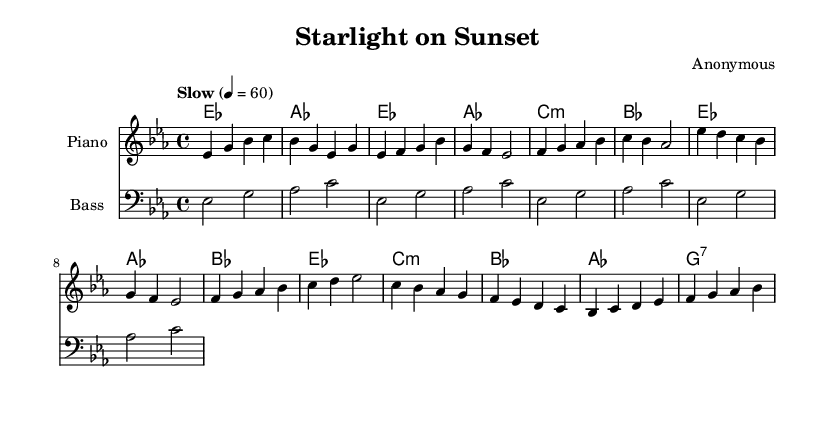what is the key signature of this music? The key signature is E-flat major, indicated by the presence of three flats (B flat, E flat, and A flat) in the music. This can be deduced from the initial clef and the indicated key of the global music part.
Answer: E-flat major what is the time signature of this music? The time signature is four-four, as indicated by the fraction displayed at the beginning of the global music part. This signifies that there are four beats per measure and the quarter note gets one beat.
Answer: four-four what is the tempo indicated in the music? The tempo marking reads "Slow" with a metronome marking of 60 beats per minute. This notation provides a clear indication of how quickly the piece should be played, allowing for a relaxed and expressive performance.
Answer: Slow, 60 how many measures are in the verse? The verse consists of four measures. This can be identified by counting the number of bar lines through the section labeled as "Verse" in the melody line.
Answer: four what is the relationship between the chorus and the verse? The chorus progresses from E-flat major to A-flat major, whereas the verse follows a sequence that stays within the same key. This indicates a musical contrast where the chorus often heightens the emotional content compared to the verse's foundational structure.
Answer: key contrast what kind of chord is used in the bridge section? The bridge section includes a C minor chord, which is a three-note chord made up of the first, flat third, and fifth degrees of the C major scale. This particular choice typically adds tension, creating an engaging contrast with the other sections.
Answer: C minor what genre does this piece of music primarily represent? The piece, with its soulful melodies and expressive chords, represents Rhythm and Blues, often characterized by emotional ballads and a focus on vocal expression that connects to the genre's roots in jazz and blues traditions.
Answer: Rhythm and Blues 